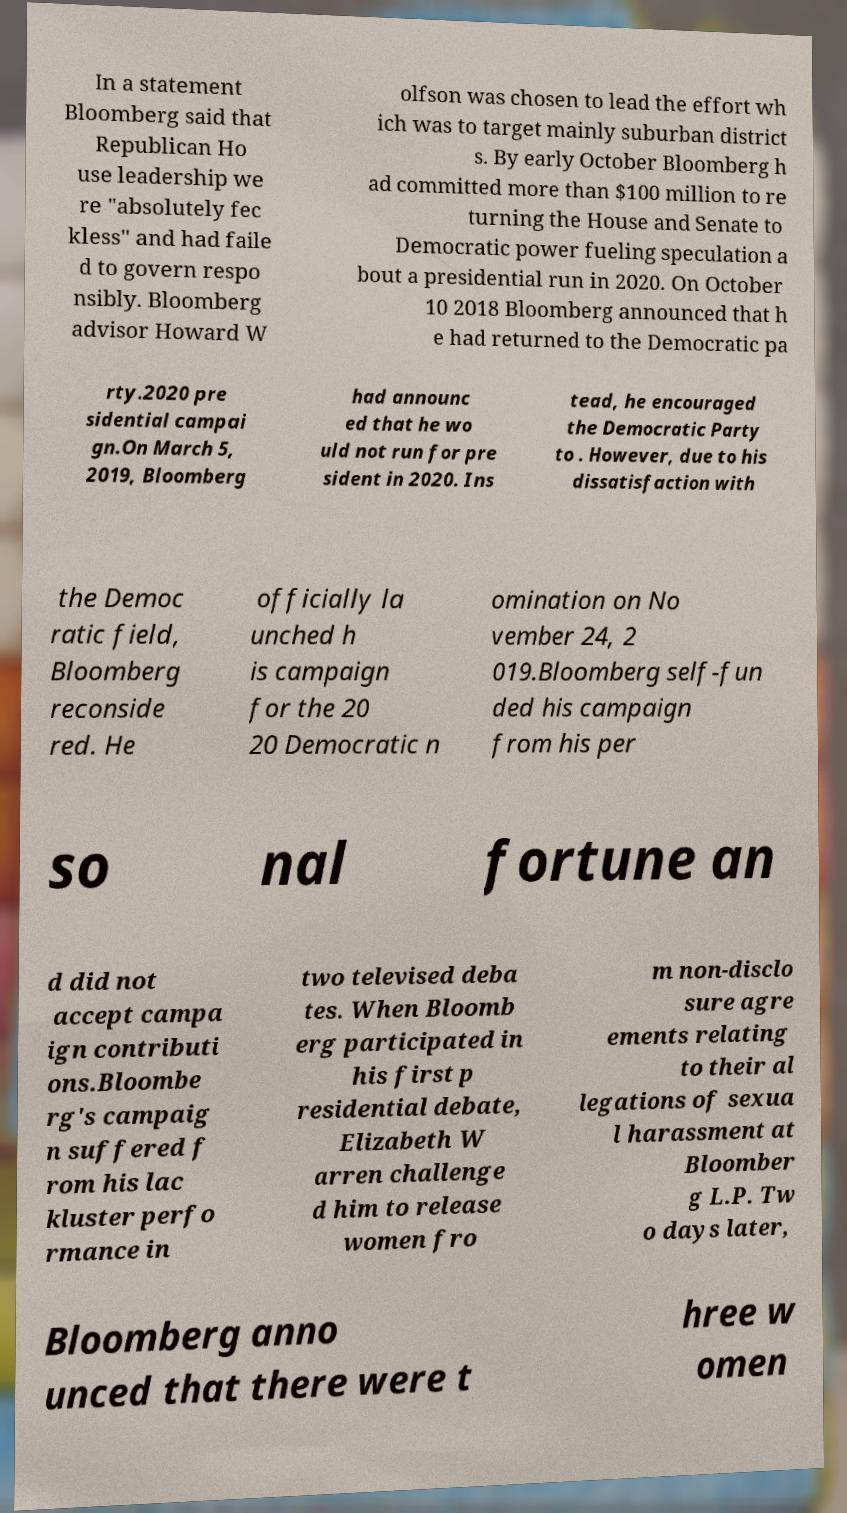Could you extract and type out the text from this image? In a statement Bloomberg said that Republican Ho use leadership we re "absolutely fec kless" and had faile d to govern respo nsibly. Bloomberg advisor Howard W olfson was chosen to lead the effort wh ich was to target mainly suburban district s. By early October Bloomberg h ad committed more than $100 million to re turning the House and Senate to Democratic power fueling speculation a bout a presidential run in 2020. On October 10 2018 Bloomberg announced that h e had returned to the Democratic pa rty.2020 pre sidential campai gn.On March 5, 2019, Bloomberg had announc ed that he wo uld not run for pre sident in 2020. Ins tead, he encouraged the Democratic Party to . However, due to his dissatisfaction with the Democ ratic field, Bloomberg reconside red. He officially la unched h is campaign for the 20 20 Democratic n omination on No vember 24, 2 019.Bloomberg self-fun ded his campaign from his per so nal fortune an d did not accept campa ign contributi ons.Bloombe rg's campaig n suffered f rom his lac kluster perfo rmance in two televised deba tes. When Bloomb erg participated in his first p residential debate, Elizabeth W arren challenge d him to release women fro m non-disclo sure agre ements relating to their al legations of sexua l harassment at Bloomber g L.P. Tw o days later, Bloomberg anno unced that there were t hree w omen 